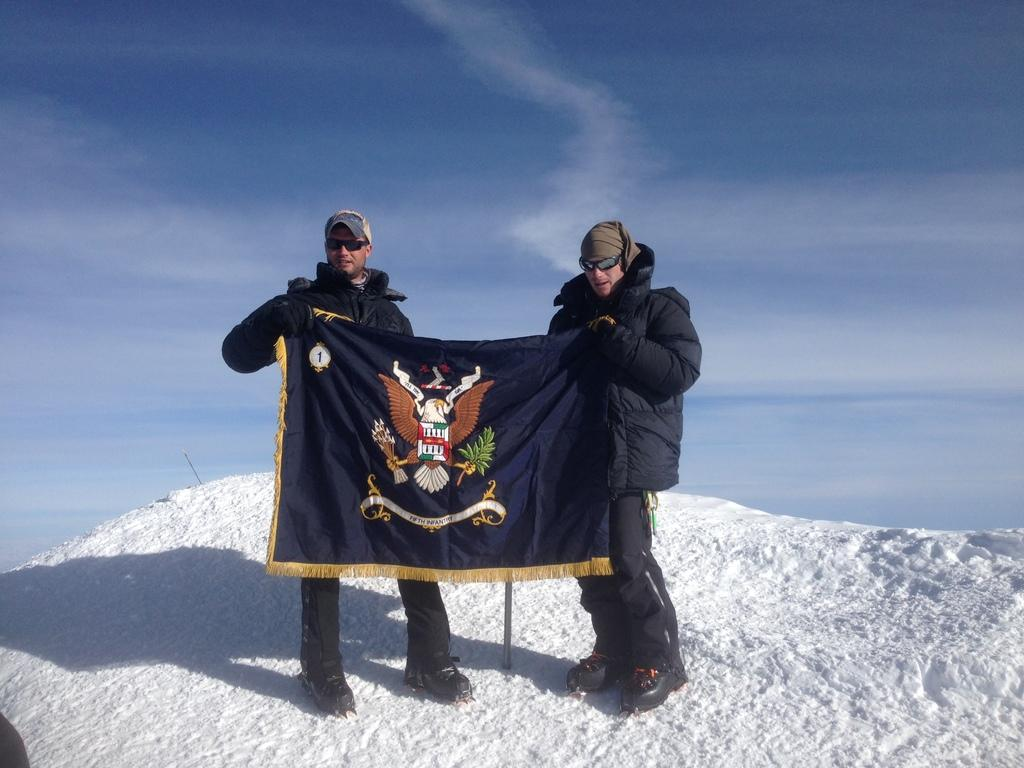How many people are in the image? There are people in the image, but the exact number is not specified. What type of clothing are the people wearing? The people are wearing coats, caps, and glasses. What are the people holding in the image? The people are holding a banner. What is visible in the background of the image? There is sky visible in the background of the image. What is the weather like in the image? The presence of snow at the bottom of the image suggests that it is snowing or has recently snowed. What type of vegetable is being added to the banner in the image? There is no vegetable present in the image, and the banner does not appear to be related to vegetables. 